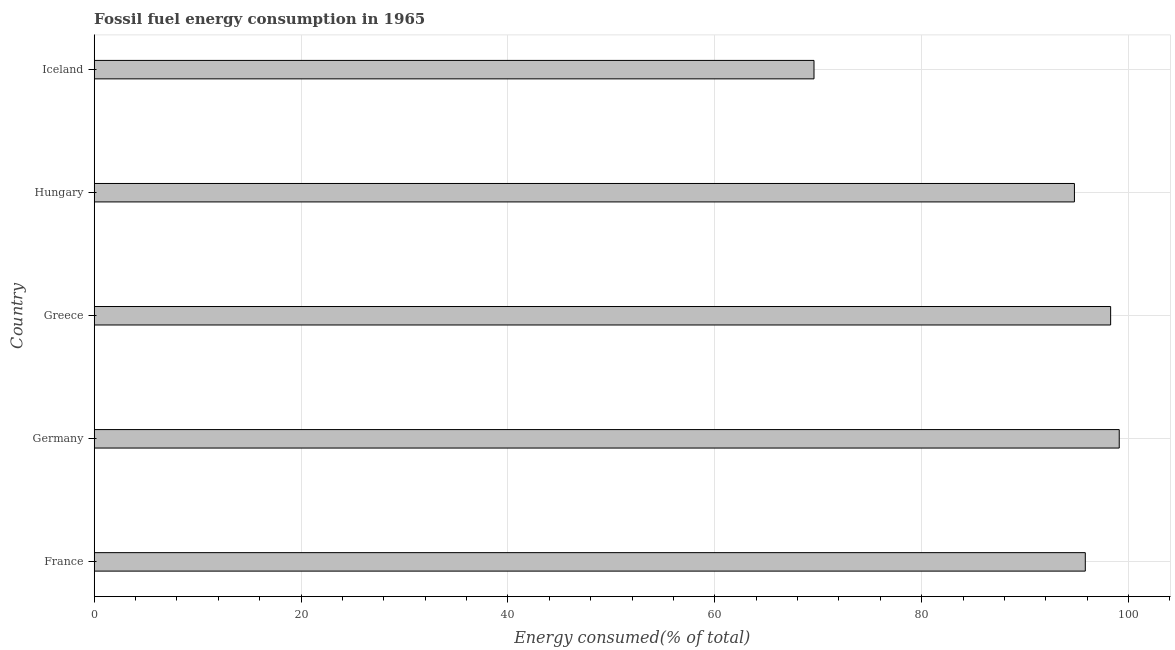Does the graph contain any zero values?
Your answer should be compact. No. Does the graph contain grids?
Your answer should be very brief. Yes. What is the title of the graph?
Keep it short and to the point. Fossil fuel energy consumption in 1965. What is the label or title of the X-axis?
Your response must be concise. Energy consumed(% of total). What is the label or title of the Y-axis?
Ensure brevity in your answer.  Country. What is the fossil fuel energy consumption in Hungary?
Provide a succinct answer. 94.77. Across all countries, what is the maximum fossil fuel energy consumption?
Give a very brief answer. 99.1. Across all countries, what is the minimum fossil fuel energy consumption?
Provide a succinct answer. 69.59. What is the sum of the fossil fuel energy consumption?
Ensure brevity in your answer.  457.55. What is the difference between the fossil fuel energy consumption in France and Hungary?
Offer a very short reply. 1.05. What is the average fossil fuel energy consumption per country?
Your answer should be very brief. 91.51. What is the median fossil fuel energy consumption?
Your answer should be very brief. 95.82. What is the ratio of the fossil fuel energy consumption in France to that in Hungary?
Provide a short and direct response. 1.01. Is the fossil fuel energy consumption in Greece less than that in Hungary?
Your response must be concise. No. What is the difference between the highest and the second highest fossil fuel energy consumption?
Make the answer very short. 0.83. What is the difference between the highest and the lowest fossil fuel energy consumption?
Provide a succinct answer. 29.51. How many bars are there?
Give a very brief answer. 5. Are the values on the major ticks of X-axis written in scientific E-notation?
Ensure brevity in your answer.  No. What is the Energy consumed(% of total) in France?
Offer a very short reply. 95.82. What is the Energy consumed(% of total) in Germany?
Your answer should be compact. 99.1. What is the Energy consumed(% of total) of Greece?
Make the answer very short. 98.27. What is the Energy consumed(% of total) in Hungary?
Keep it short and to the point. 94.77. What is the Energy consumed(% of total) in Iceland?
Make the answer very short. 69.59. What is the difference between the Energy consumed(% of total) in France and Germany?
Your response must be concise. -3.28. What is the difference between the Energy consumed(% of total) in France and Greece?
Your response must be concise. -2.45. What is the difference between the Energy consumed(% of total) in France and Hungary?
Make the answer very short. 1.05. What is the difference between the Energy consumed(% of total) in France and Iceland?
Your answer should be compact. 26.23. What is the difference between the Energy consumed(% of total) in Germany and Greece?
Ensure brevity in your answer.  0.83. What is the difference between the Energy consumed(% of total) in Germany and Hungary?
Offer a very short reply. 4.33. What is the difference between the Energy consumed(% of total) in Germany and Iceland?
Offer a terse response. 29.51. What is the difference between the Energy consumed(% of total) in Greece and Hungary?
Your answer should be very brief. 3.5. What is the difference between the Energy consumed(% of total) in Greece and Iceland?
Your answer should be compact. 28.68. What is the difference between the Energy consumed(% of total) in Hungary and Iceland?
Provide a succinct answer. 25.18. What is the ratio of the Energy consumed(% of total) in France to that in Iceland?
Provide a succinct answer. 1.38. What is the ratio of the Energy consumed(% of total) in Germany to that in Greece?
Make the answer very short. 1.01. What is the ratio of the Energy consumed(% of total) in Germany to that in Hungary?
Offer a very short reply. 1.05. What is the ratio of the Energy consumed(% of total) in Germany to that in Iceland?
Provide a short and direct response. 1.42. What is the ratio of the Energy consumed(% of total) in Greece to that in Iceland?
Give a very brief answer. 1.41. What is the ratio of the Energy consumed(% of total) in Hungary to that in Iceland?
Your response must be concise. 1.36. 